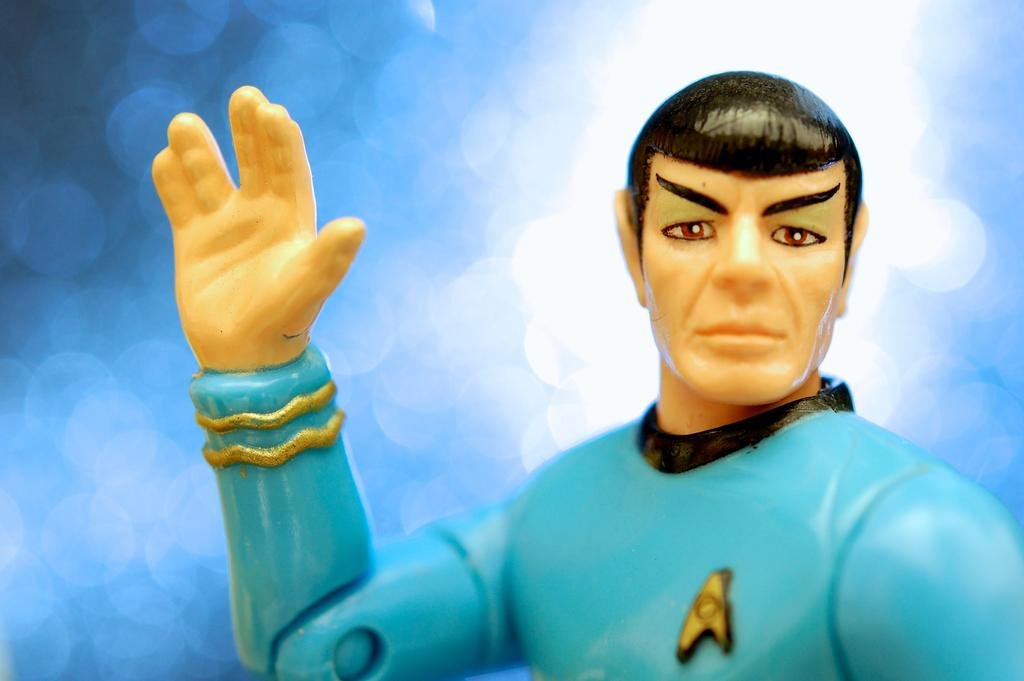What object in the picture can be considered a toy? There is a toy in the picture, but the specific toy cannot be determined from the given fact. What type of suit is the toy wearing in the image? There is no suit or any clothing mentioned in the image, as the only fact provided is that there is a toy present. 